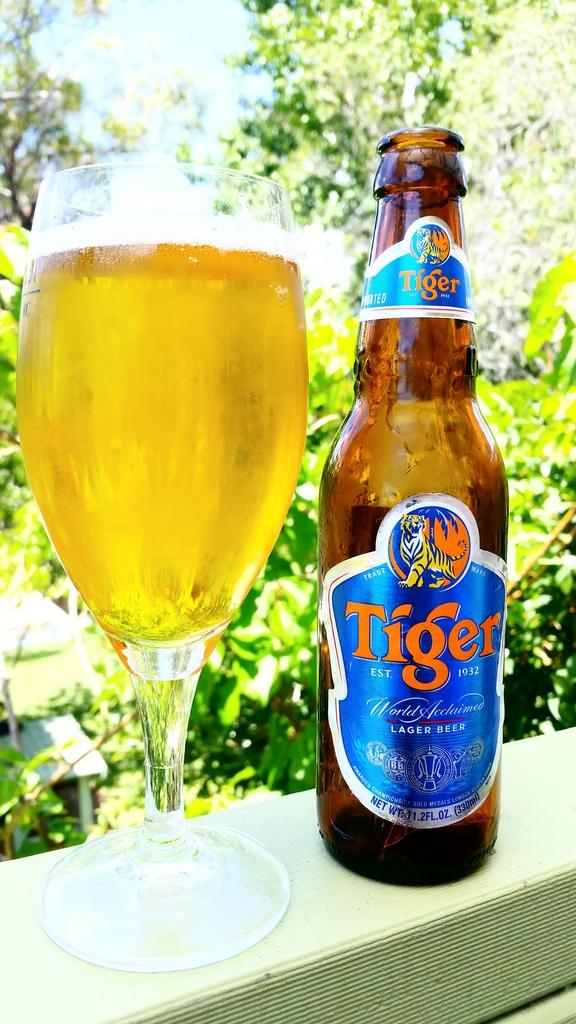What is the name of this lager?
Keep it short and to the point. Tiger. What year was tiger established?
Your response must be concise. 1932. 